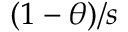Convert formula to latex. <formula><loc_0><loc_0><loc_500><loc_500>( 1 - \theta ) / s</formula> 